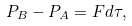Convert formula to latex. <formula><loc_0><loc_0><loc_500><loc_500>P _ { B } - P _ { A } = F d \tau ,</formula> 